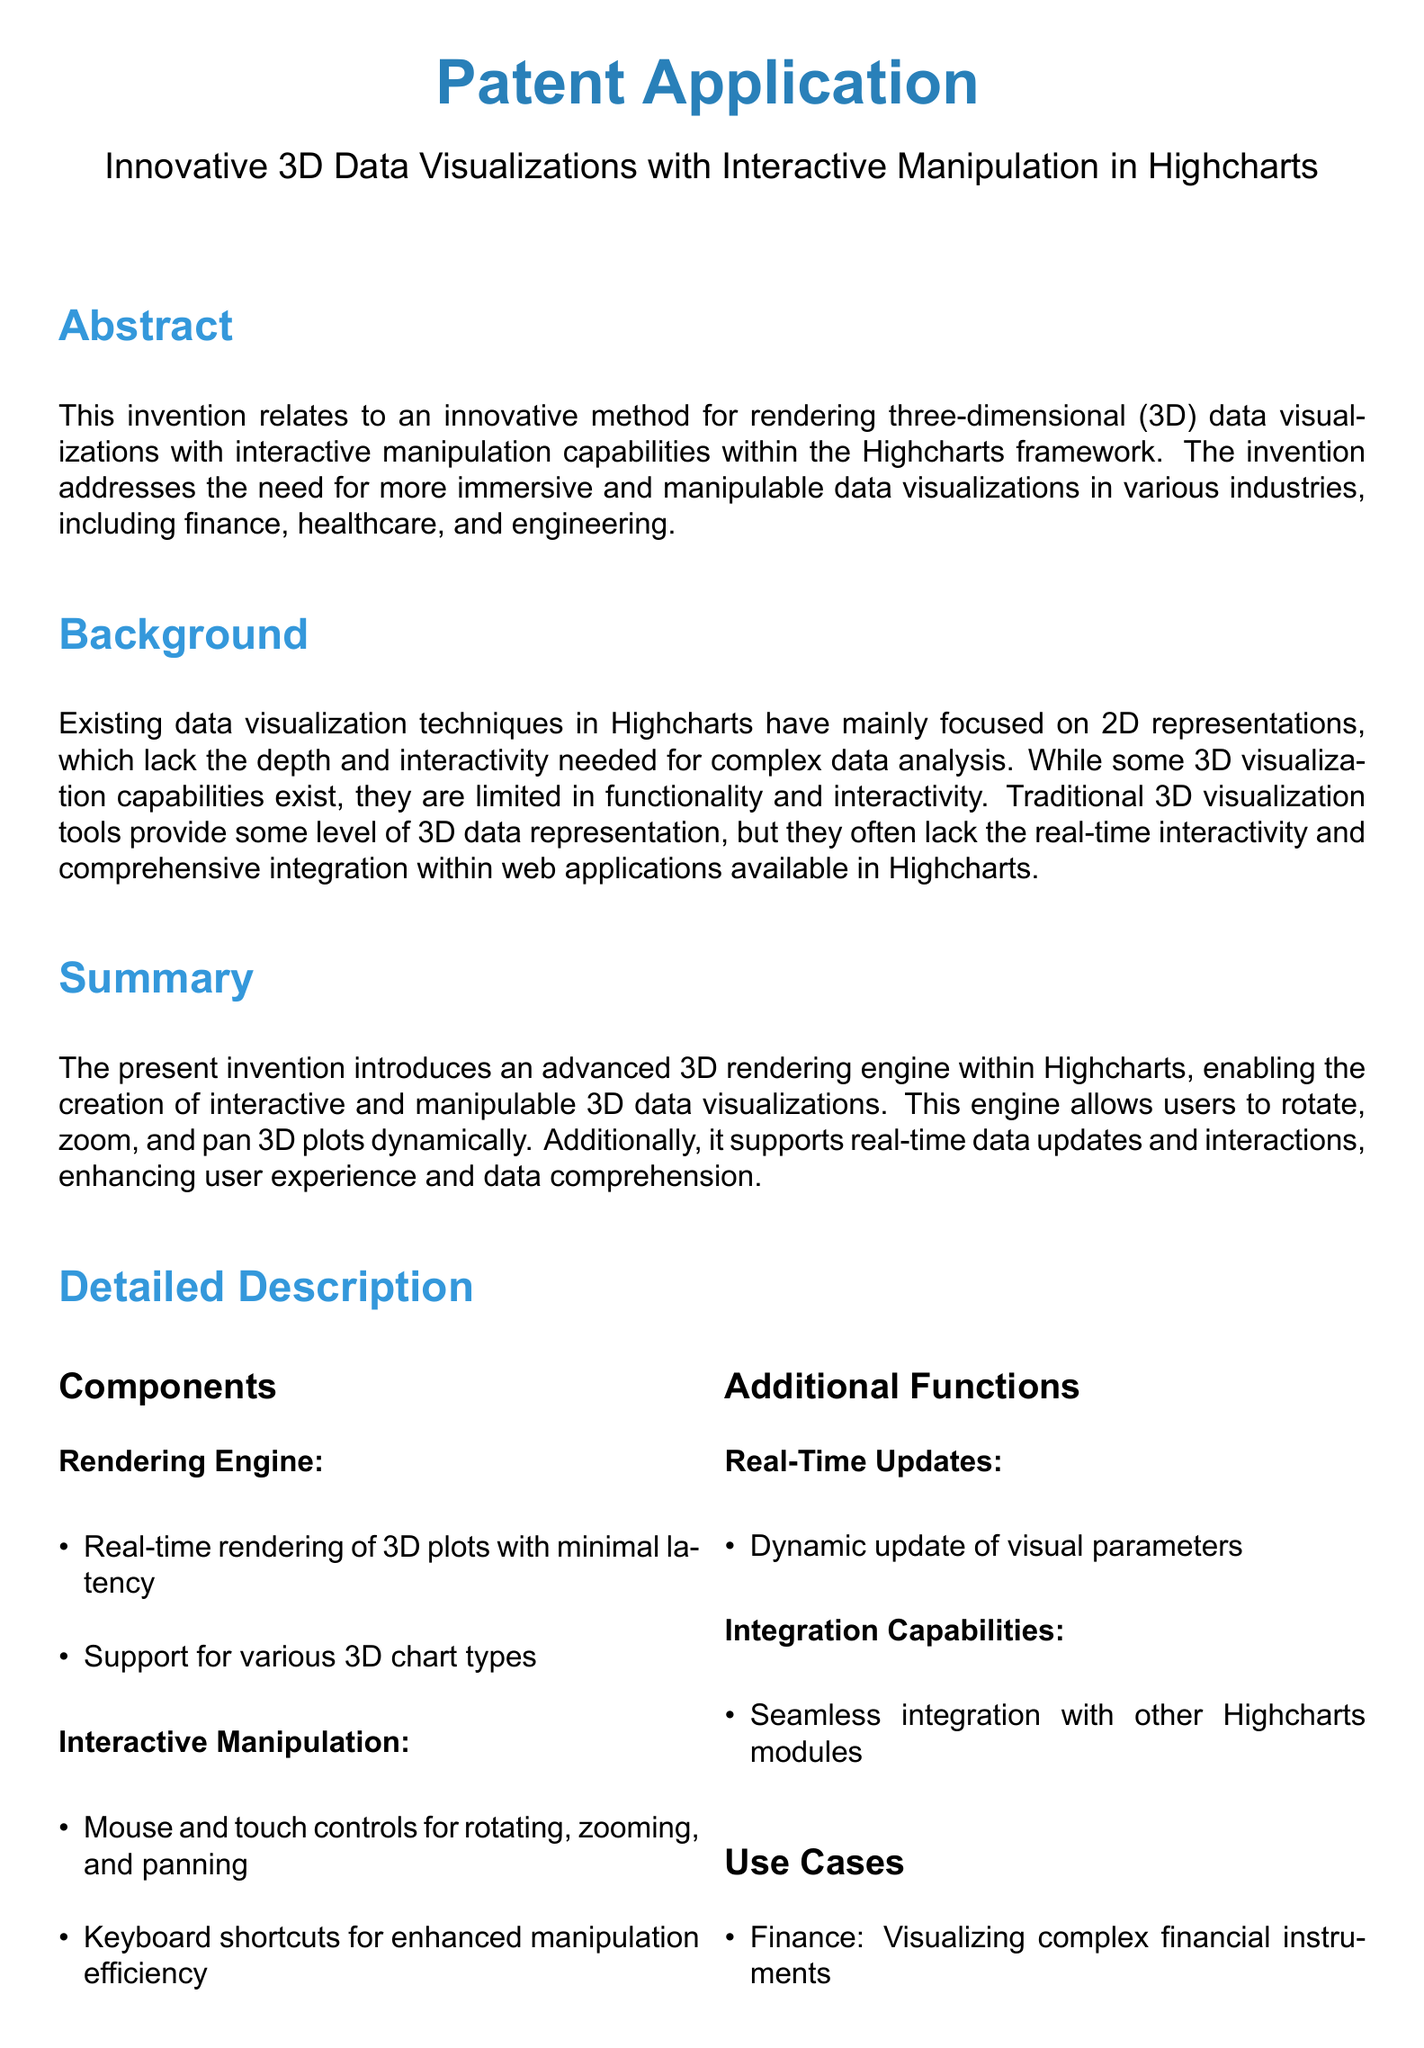What is the title of the patent application? The title is stated at the beginning of the document as "Innovative 3D Data Visualizations with Interactive Manipulation in Highcharts."
Answer: Innovative 3D Data Visualizations with Interactive Manipulation in Highcharts What is the primary focus of this invention? The primary focus is outlined in the abstract, which mentions rendering three-dimensional data visualizations with interactive manipulation capabilities.
Answer: Rendering 3D data visualizations with interactive manipulation capabilities Which industries are mentioned as beneficiaries of this innovation? The document lists specific industries in the background section, including finance, healthcare, and engineering.
Answer: Finance, healthcare, engineering What types of chart does the rendering engine support? The document specifies that it supports various 3D chart types under the "Rendering Engine" section.
Answer: Various 3D chart types What interactive controls does the invention offer for 3D visualizations? The "Interactive Manipulation" section lists mouse and touch controls as well as keyboard shortcuts.
Answer: Mouse, touch, keyboard shortcuts What is one key feature of the real-time updates described? The detailed description mentions dynamic update of visual parameters as a key feature of real-time updates.
Answer: Dynamic update of visual parameters How many claims are presented in this patent application? The number of claims is stated in the "Claims" section, which lists three claims.
Answer: Three Name one use case mentioned for the 3D visualization technology. The document lists use cases for finance, healthcare, and engineering, any of which can be a valid answer.
Answer: Finance 